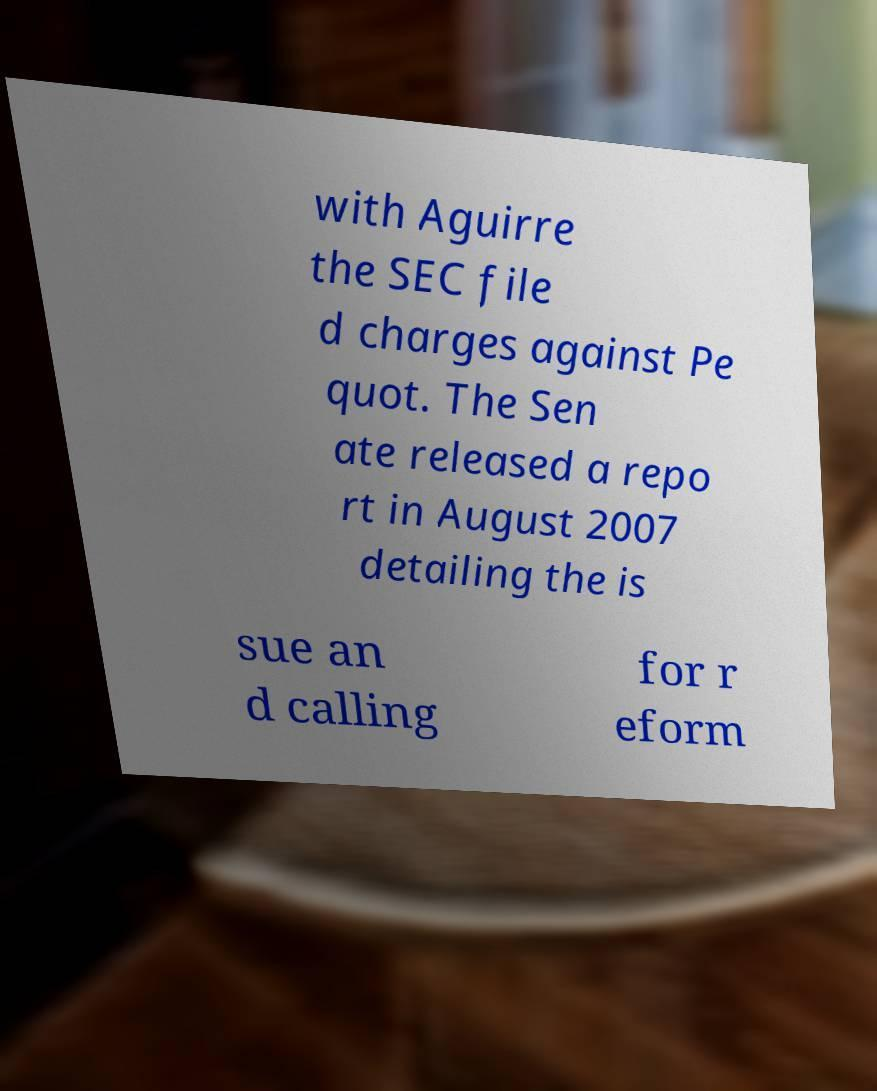Can you read and provide the text displayed in the image?This photo seems to have some interesting text. Can you extract and type it out for me? with Aguirre the SEC file d charges against Pe quot. The Sen ate released a repo rt in August 2007 detailing the is sue an d calling for r eform 